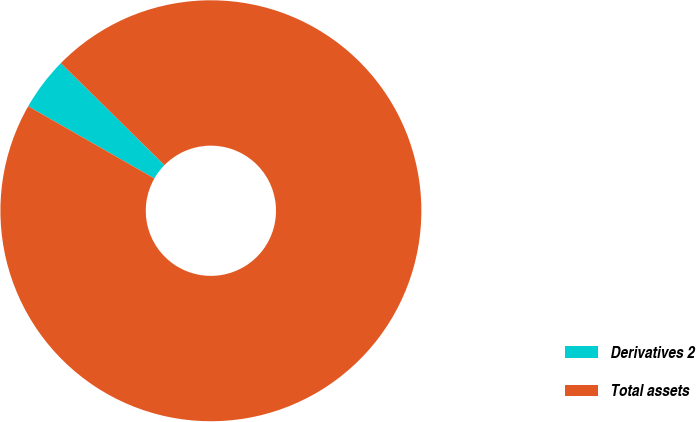Convert chart. <chart><loc_0><loc_0><loc_500><loc_500><pie_chart><fcel>Derivatives 2<fcel>Total assets<nl><fcel>4.1%<fcel>95.9%<nl></chart> 